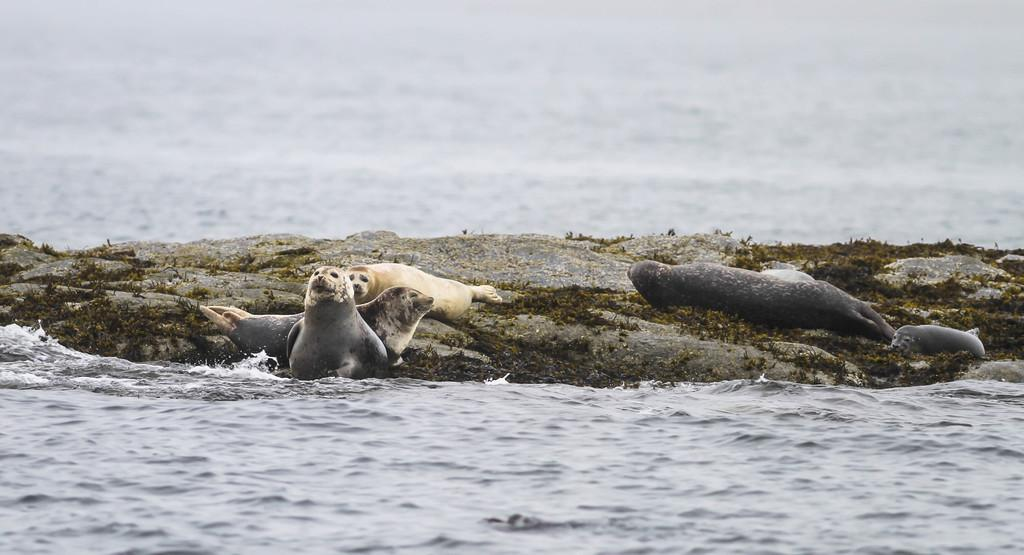What type of natural feature is present in the image? There is a water body in the image. What animals can be seen in the center of the image? There are seals in the center of the image. What type of vegetation is present in the center of the image? There is grass in the center of the image. What type of terrain is present in the center of the image? There is land in the center of the image. Where is the crowd gathered to watch the cloth being spun in the image? There is no crowd or cloth present in the image; it features a water body, seals, grass, and land. 